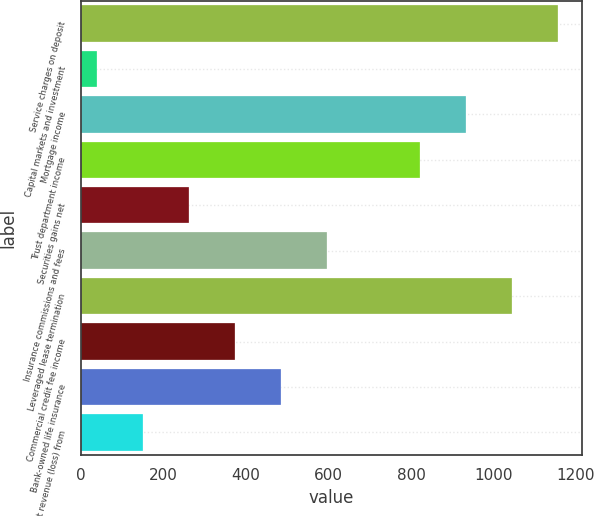<chart> <loc_0><loc_0><loc_500><loc_500><bar_chart><fcel>Service charges on deposit<fcel>Capital markets and investment<fcel>Mortgage income<fcel>Trust department income<fcel>Securities gains net<fcel>Insurance commissions and fees<fcel>Leveraged lease termination<fcel>Commercial credit fee income<fcel>Bank-owned life insurance<fcel>Net revenue (loss) from<nl><fcel>1156<fcel>39<fcel>932.6<fcel>820.9<fcel>262.4<fcel>597.5<fcel>1044.3<fcel>374.1<fcel>485.8<fcel>150.7<nl></chart> 